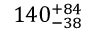Convert formula to latex. <formula><loc_0><loc_0><loc_500><loc_500>1 4 0 _ { - 3 8 } ^ { + 8 4 }</formula> 